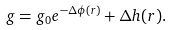<formula> <loc_0><loc_0><loc_500><loc_500>g = g _ { 0 } e ^ { - \Delta \phi ( r ) } + \Delta h ( r ) .</formula> 